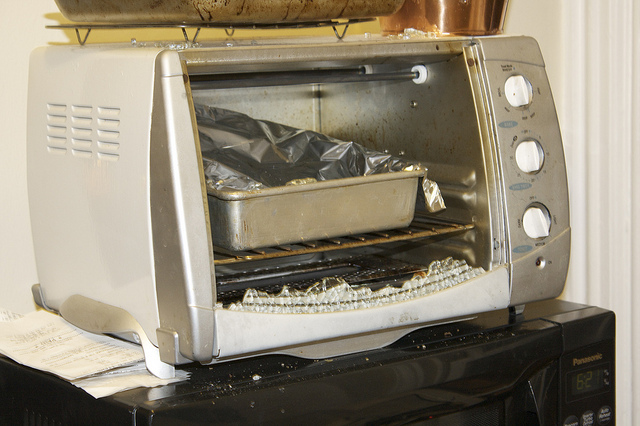Please extract the text content from this image. 62 